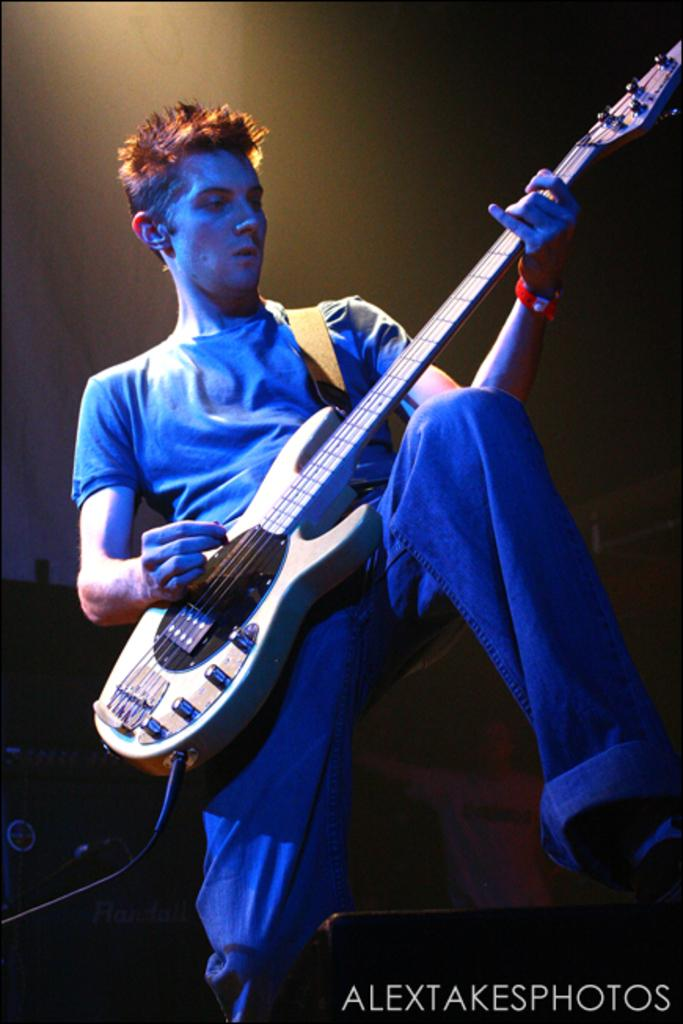What is the main subject of the image? There is a person in the image. What is the person doing in the image? The person is playing a guitar. What type of account does the person have trouble with in the image? There is no mention of an account or any trouble in the image; it simply shows a person playing a guitar. 